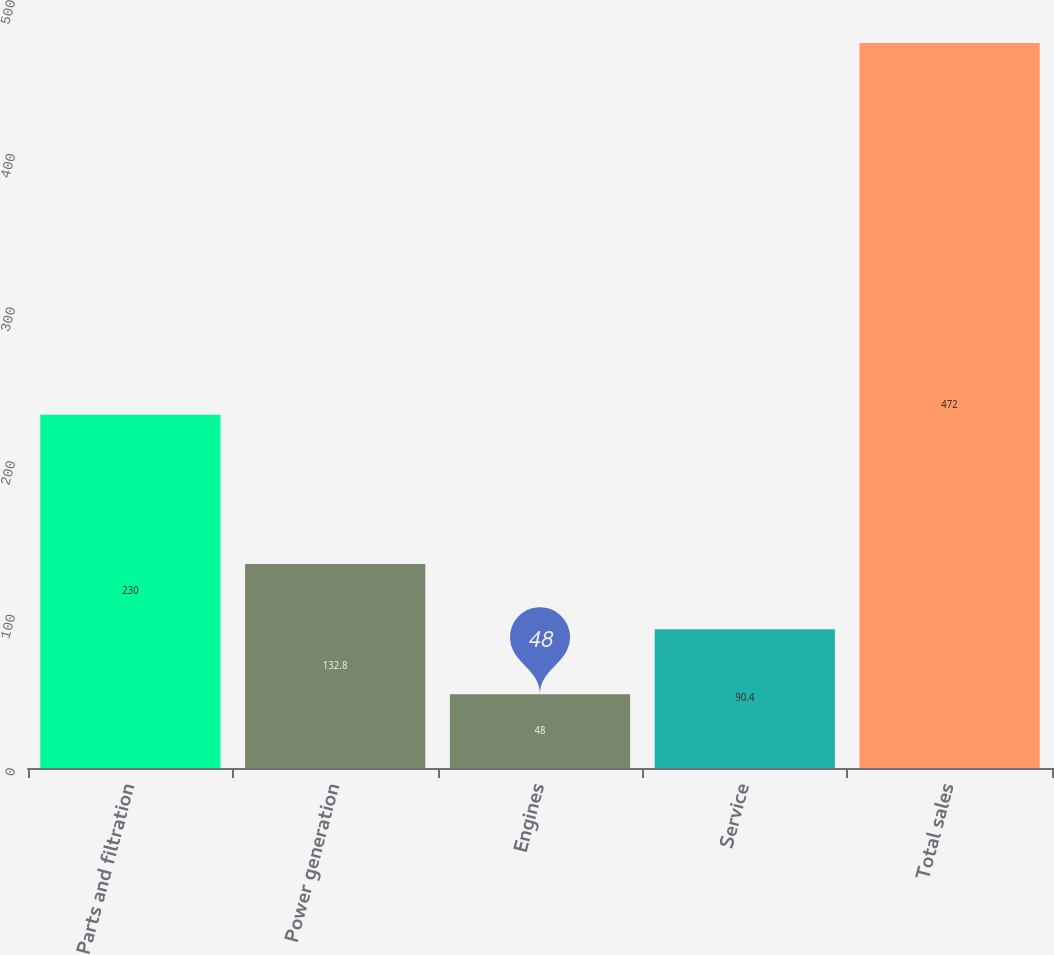<chart> <loc_0><loc_0><loc_500><loc_500><bar_chart><fcel>Parts and filtration<fcel>Power generation<fcel>Engines<fcel>Service<fcel>Total sales<nl><fcel>230<fcel>132.8<fcel>48<fcel>90.4<fcel>472<nl></chart> 